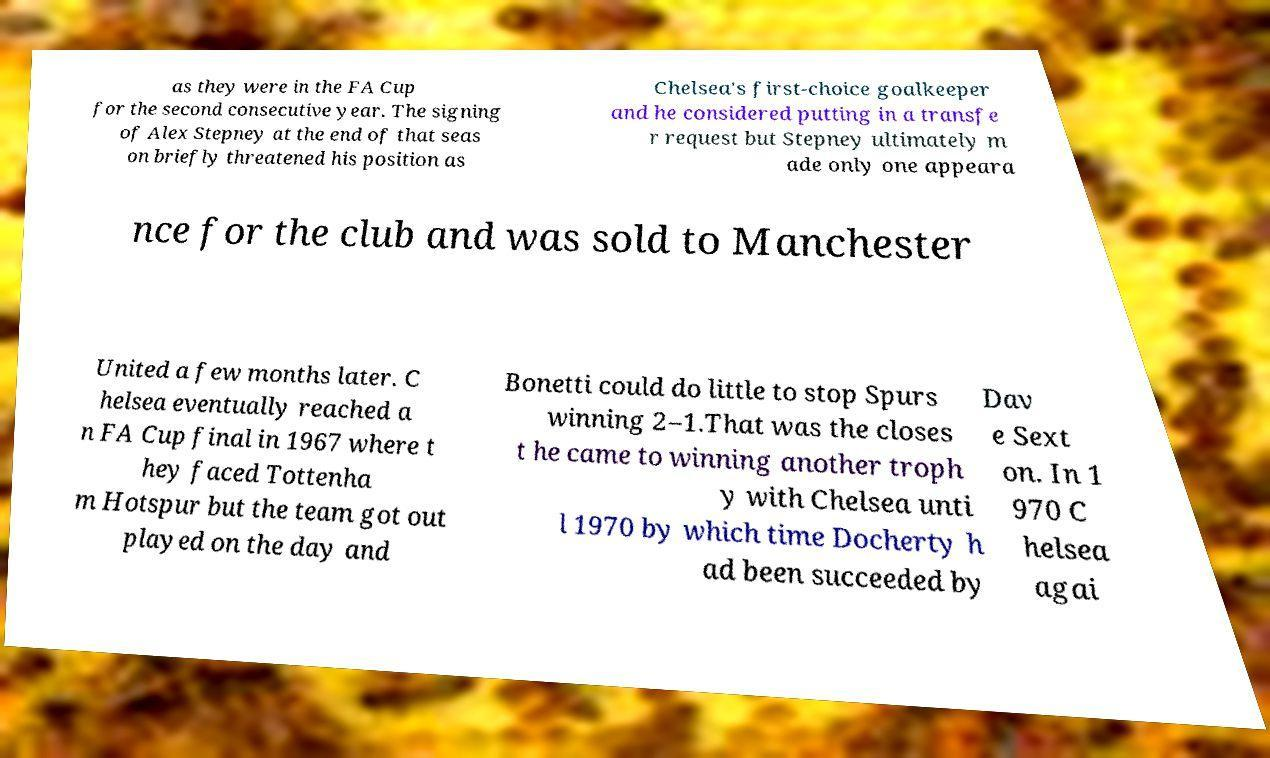Could you extract and type out the text from this image? as they were in the FA Cup for the second consecutive year. The signing of Alex Stepney at the end of that seas on briefly threatened his position as Chelsea's first-choice goalkeeper and he considered putting in a transfe r request but Stepney ultimately m ade only one appeara nce for the club and was sold to Manchester United a few months later. C helsea eventually reached a n FA Cup final in 1967 where t hey faced Tottenha m Hotspur but the team got out played on the day and Bonetti could do little to stop Spurs winning 2–1.That was the closes t he came to winning another troph y with Chelsea unti l 1970 by which time Docherty h ad been succeeded by Dav e Sext on. In 1 970 C helsea agai 